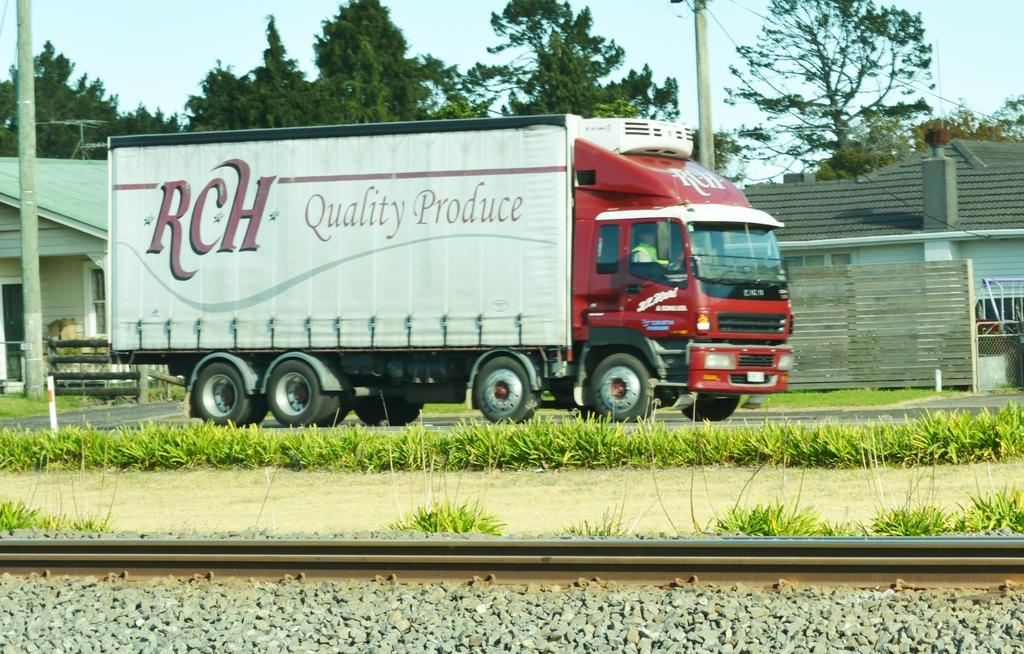What is the person in the image doing? The person is sitting inside a vehicle in the image. What celestial bodies can be seen in the image? There are planets visible in the image. What type of transportation infrastructure is present in the image? There are railway tracks in the image. What type of structures are visible in the image? There are buildings in the image. What type of vertical structures are present in the image? There are poles in the image. What type of vegetation is visible in the image? There are trees in the image. What is visible in the background of the image? The sky is visible in the background of the image. What type of window is visible in the image? There is no window present in the image. 